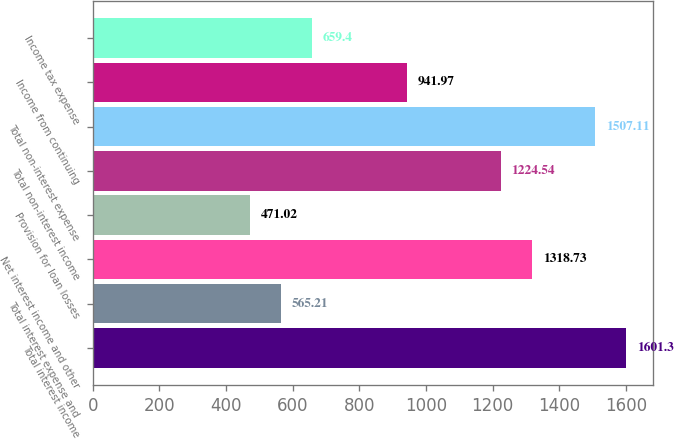<chart> <loc_0><loc_0><loc_500><loc_500><bar_chart><fcel>Total interest income<fcel>Total interest expense and<fcel>Net interest income and other<fcel>Provision for loan losses<fcel>Total non-interest income<fcel>Total non-interest expense<fcel>Income from continuing<fcel>Income tax expense<nl><fcel>1601.3<fcel>565.21<fcel>1318.73<fcel>471.02<fcel>1224.54<fcel>1507.11<fcel>941.97<fcel>659.4<nl></chart> 